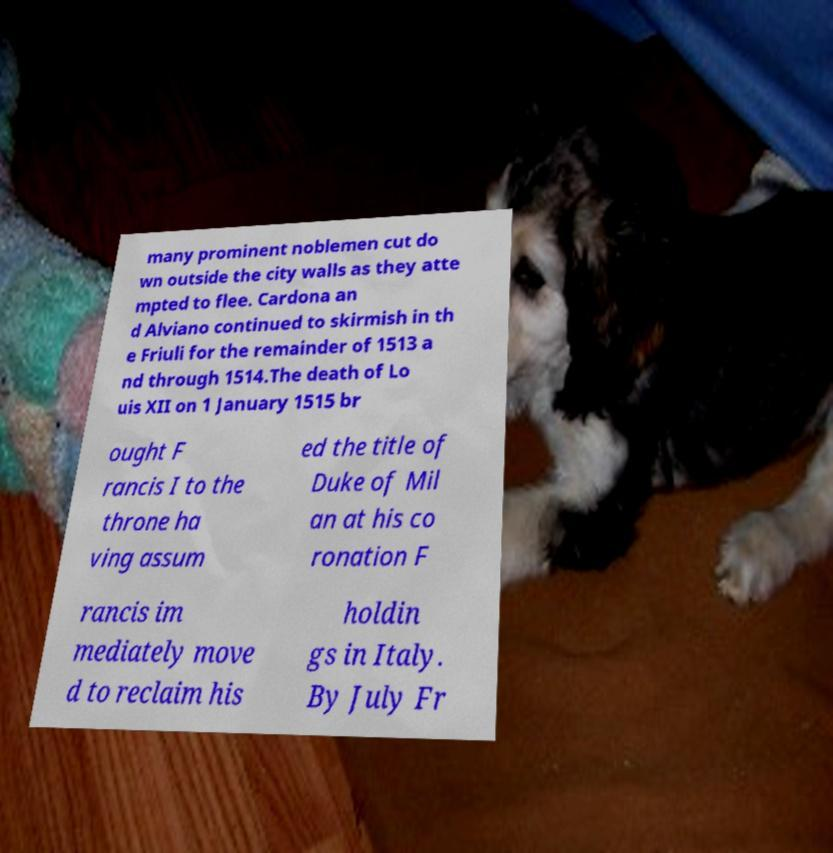Can you accurately transcribe the text from the provided image for me? many prominent noblemen cut do wn outside the city walls as they atte mpted to flee. Cardona an d Alviano continued to skirmish in th e Friuli for the remainder of 1513 a nd through 1514.The death of Lo uis XII on 1 January 1515 br ought F rancis I to the throne ha ving assum ed the title of Duke of Mil an at his co ronation F rancis im mediately move d to reclaim his holdin gs in Italy. By July Fr 